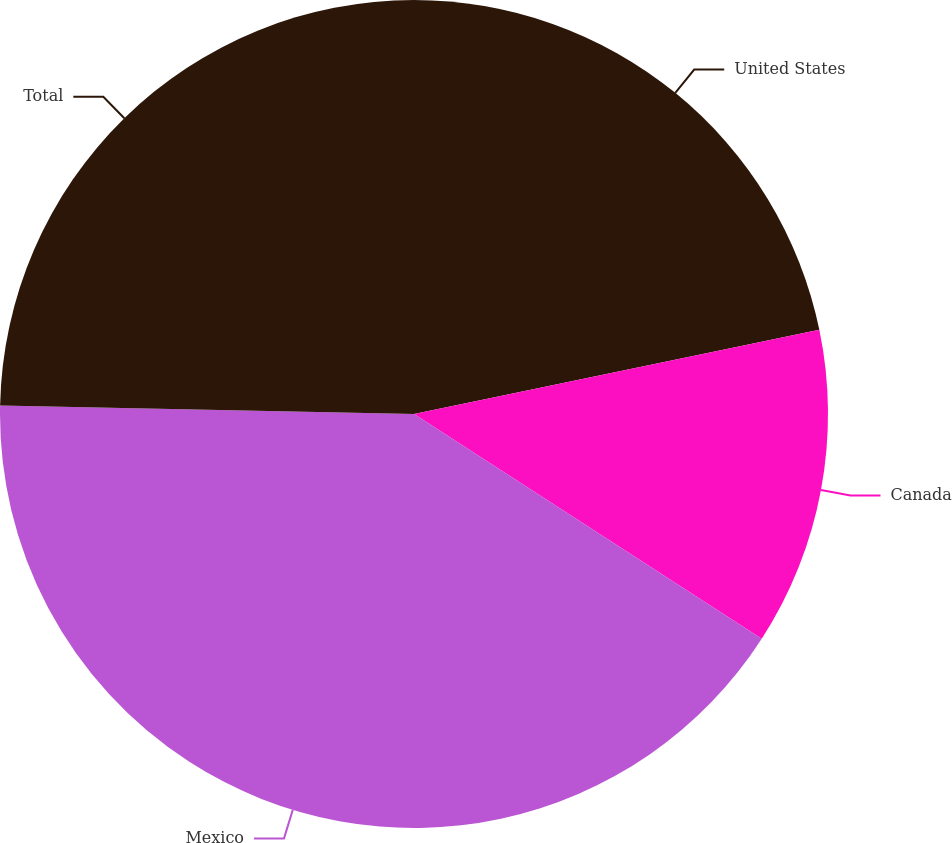Convert chart. <chart><loc_0><loc_0><loc_500><loc_500><pie_chart><fcel>United States<fcel>Canada<fcel>Mexico<fcel>Total<nl><fcel>21.74%<fcel>12.39%<fcel>41.2%<fcel>24.67%<nl></chart> 